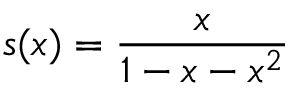<formula> <loc_0><loc_0><loc_500><loc_500>s ( x ) = { \frac { x } { 1 - x - x ^ { 2 } } }</formula> 